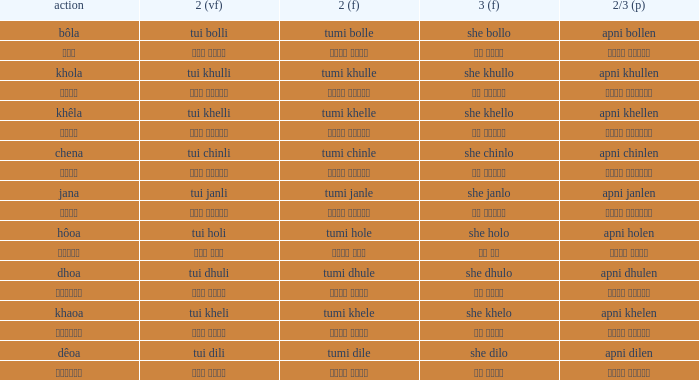What is the 3rd for the 2nd Tui Dhuli? She dhulo. 